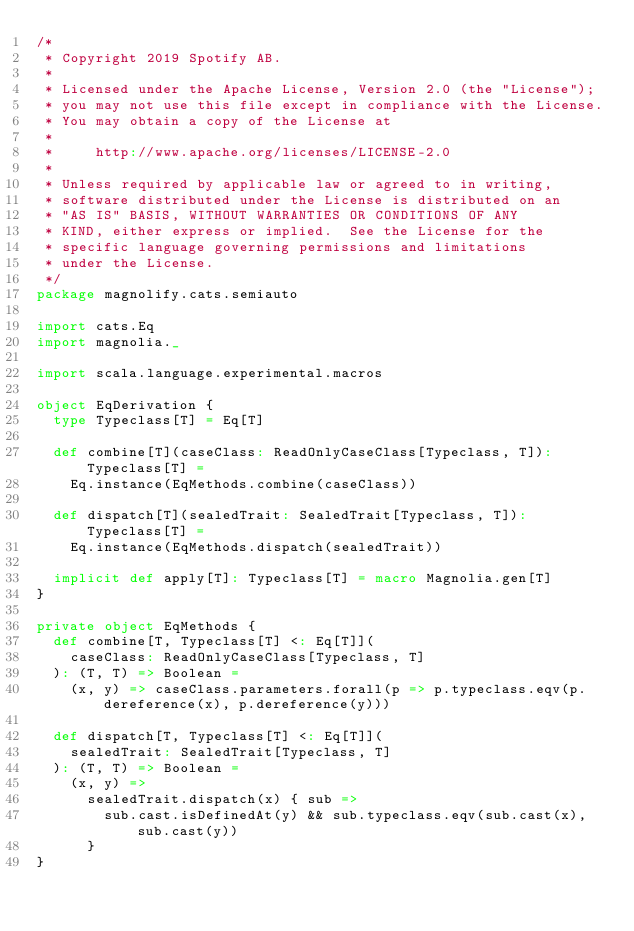Convert code to text. <code><loc_0><loc_0><loc_500><loc_500><_Scala_>/*
 * Copyright 2019 Spotify AB.
 *
 * Licensed under the Apache License, Version 2.0 (the "License");
 * you may not use this file except in compliance with the License.
 * You may obtain a copy of the License at
 *
 *     http://www.apache.org/licenses/LICENSE-2.0
 *
 * Unless required by applicable law or agreed to in writing,
 * software distributed under the License is distributed on an
 * "AS IS" BASIS, WITHOUT WARRANTIES OR CONDITIONS OF ANY
 * KIND, either express or implied.  See the License for the
 * specific language governing permissions and limitations
 * under the License.
 */
package magnolify.cats.semiauto

import cats.Eq
import magnolia._

import scala.language.experimental.macros

object EqDerivation {
  type Typeclass[T] = Eq[T]

  def combine[T](caseClass: ReadOnlyCaseClass[Typeclass, T]): Typeclass[T] =
    Eq.instance(EqMethods.combine(caseClass))

  def dispatch[T](sealedTrait: SealedTrait[Typeclass, T]): Typeclass[T] =
    Eq.instance(EqMethods.dispatch(sealedTrait))

  implicit def apply[T]: Typeclass[T] = macro Magnolia.gen[T]
}

private object EqMethods {
  def combine[T, Typeclass[T] <: Eq[T]](
    caseClass: ReadOnlyCaseClass[Typeclass, T]
  ): (T, T) => Boolean =
    (x, y) => caseClass.parameters.forall(p => p.typeclass.eqv(p.dereference(x), p.dereference(y)))

  def dispatch[T, Typeclass[T] <: Eq[T]](
    sealedTrait: SealedTrait[Typeclass, T]
  ): (T, T) => Boolean =
    (x, y) =>
      sealedTrait.dispatch(x) { sub =>
        sub.cast.isDefinedAt(y) && sub.typeclass.eqv(sub.cast(x), sub.cast(y))
      }
}
</code> 